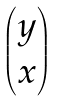<formula> <loc_0><loc_0><loc_500><loc_500>\begin{pmatrix} y \\ x \\ \end{pmatrix}</formula> 